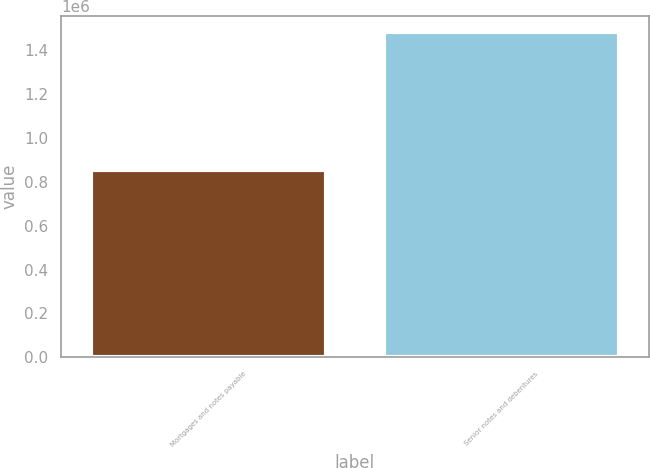Convert chart to OTSL. <chart><loc_0><loc_0><loc_500><loc_500><bar_chart><fcel>Mortgages and notes payable<fcel>Senior notes and debentures<nl><fcel>854217<fcel>1.48381e+06<nl></chart> 